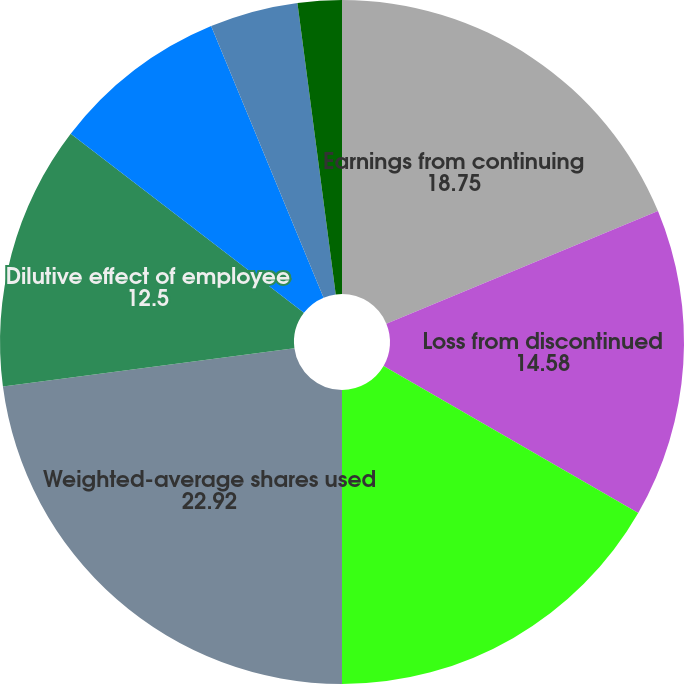<chart> <loc_0><loc_0><loc_500><loc_500><pie_chart><fcel>Earnings from continuing<fcel>Loss from discontinued<fcel>Net earnings<fcel>Weighted-average shares used<fcel>Dilutive effect of employee<fcel>Continuing operations<fcel>Discontinued operations<fcel>Basic net earnings per share<fcel>Discontinued operations (2)<nl><fcel>18.75%<fcel>14.58%<fcel>16.67%<fcel>22.92%<fcel>12.5%<fcel>8.33%<fcel>0.0%<fcel>4.17%<fcel>2.08%<nl></chart> 